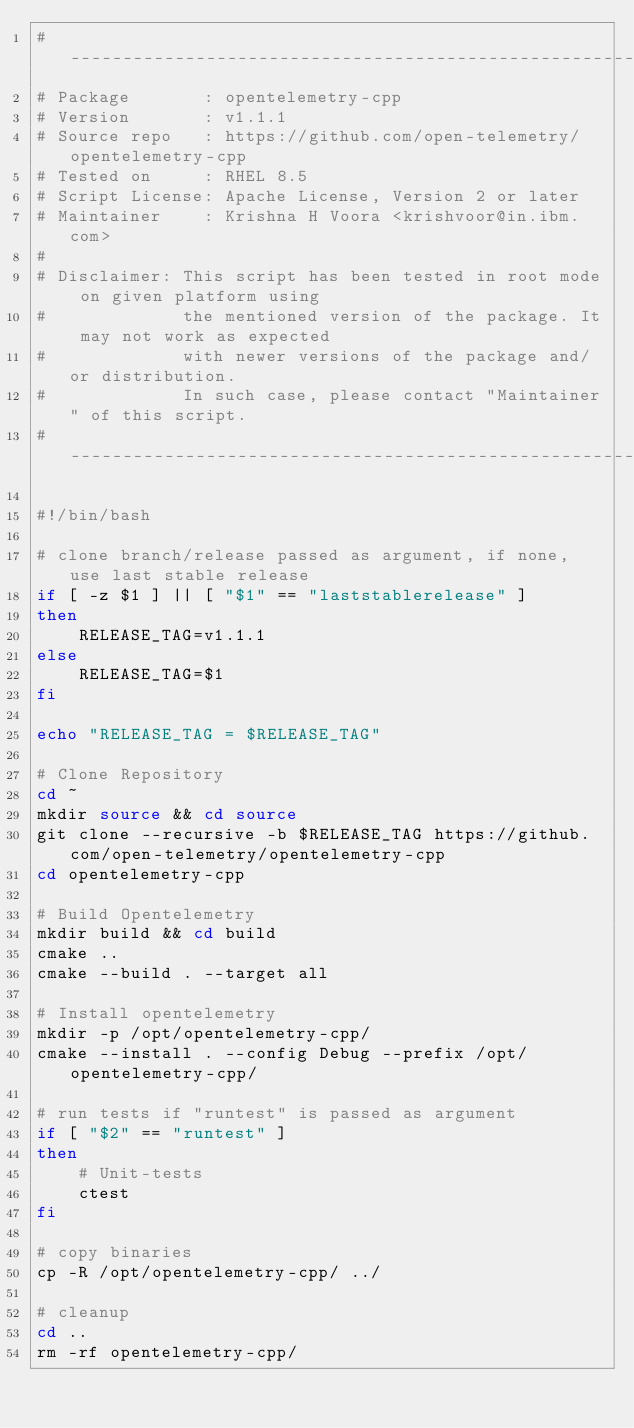Convert code to text. <code><loc_0><loc_0><loc_500><loc_500><_Bash_># --------------------------------------------------------------------------------
# Package       : opentelemetry-cpp
# Version       : v1.1.1
# Source repo   : https://github.com/open-telemetry/opentelemetry-cpp
# Tested on     : RHEL 8.5
# Script License: Apache License, Version 2 or later
# Maintainer    : Krishna H Voora <krishvoor@in.ibm.com>
#
# Disclaimer: This script has been tested in root mode on given platform using
#             the mentioned version of the package. It may not work as expected 
#             with newer versions of the package and/or distribution.
#             In such case, please contact "Maintainer" of this script.
# --------------------------------------------------------------------------------

#!/bin/bash

# clone branch/release passed as argument, if none, use last stable release
if [ -z $1 ] || [ "$1" == "laststablerelease" ]
then
	RELEASE_TAG=v1.1.1
else
	RELEASE_TAG=$1
fi

echo "RELEASE_TAG = $RELEASE_TAG"

# Clone Repository
cd ~
mkdir source && cd source
git clone --recursive -b $RELEASE_TAG https://github.com/open-telemetry/opentelemetry-cpp
cd opentelemetry-cpp

# Build Opentelemetry
mkdir build && cd build
cmake ..
cmake --build . --target all

# Install opentelemetry
mkdir -p /opt/opentelemetry-cpp/
cmake --install . --config Debug --prefix /opt/opentelemetry-cpp/

# run tests if "runtest" is passed as argument
if [ "$2" == "runtest" ]
then
	# Unit-tests
	ctest
fi

# copy binaries
cp -R /opt/opentelemetry-cpp/ ../

# cleanup
cd ..
rm -rf opentelemetry-cpp/
</code> 